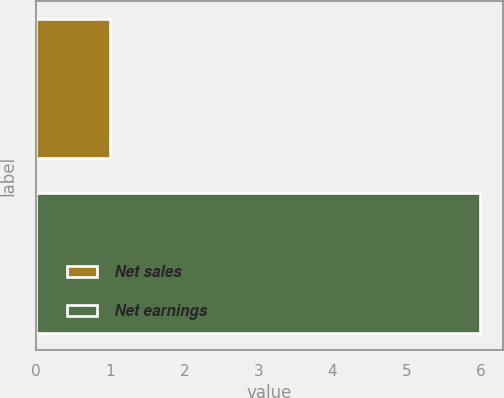Convert chart to OTSL. <chart><loc_0><loc_0><loc_500><loc_500><bar_chart><fcel>Net sales<fcel>Net earnings<nl><fcel>1<fcel>6<nl></chart> 